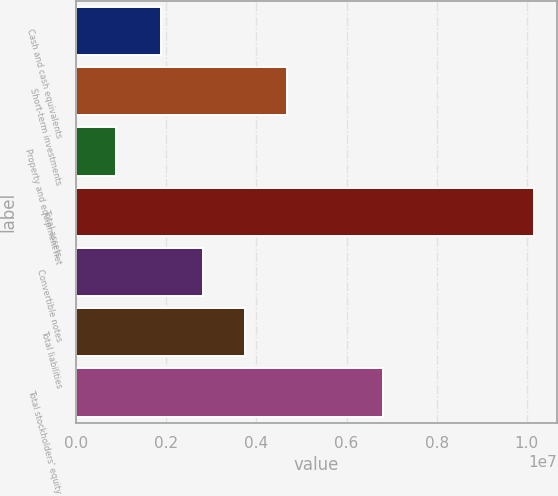<chart> <loc_0><loc_0><loc_500><loc_500><bar_chart><fcel>Cash and cash equivalents<fcel>Short-term investments<fcel>Property and equipment net<fcel>Total assets<fcel>Convertible notes<fcel>Total liabilities<fcel>Total stockholders' equity<nl><fcel>1.89444e+06<fcel>4.67769e+06<fcel>885078<fcel>1.01626e+07<fcel>2.82219e+06<fcel>3.74994e+06<fcel>6.80559e+06<nl></chart> 